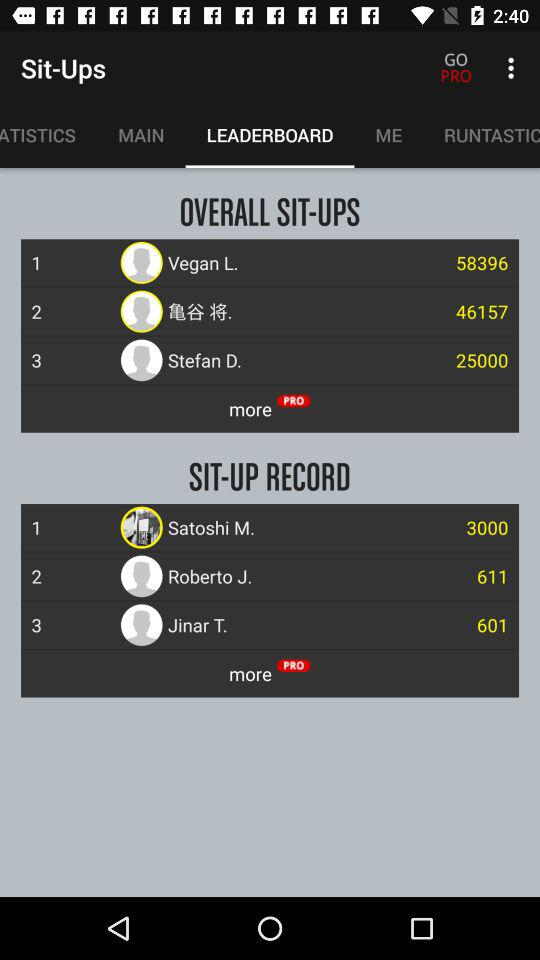What is the "SIT-UP RECORD" of Jinar T.? The "SIT-UP RECORD" of Jinar T. is 601. 